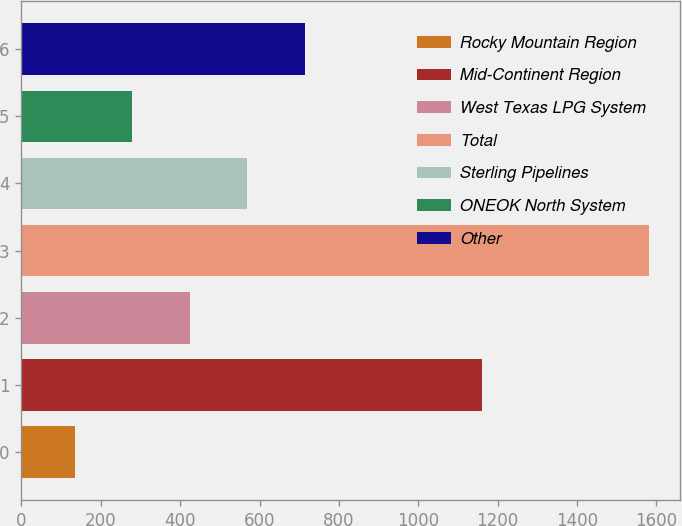Convert chart. <chart><loc_0><loc_0><loc_500><loc_500><bar_chart><fcel>Rocky Mountain Region<fcel>Mid-Continent Region<fcel>West Texas LPG System<fcel>Total<fcel>Sterling Pipelines<fcel>ONEOK North System<fcel>Other<nl><fcel>135<fcel>1161<fcel>424.2<fcel>1581<fcel>568.8<fcel>279.6<fcel>713.4<nl></chart> 